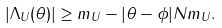Convert formula to latex. <formula><loc_0><loc_0><loc_500><loc_500>| \Lambda _ { U } ( \theta ) | \geq m _ { U } - | \theta - \phi | N m _ { U } .</formula> 